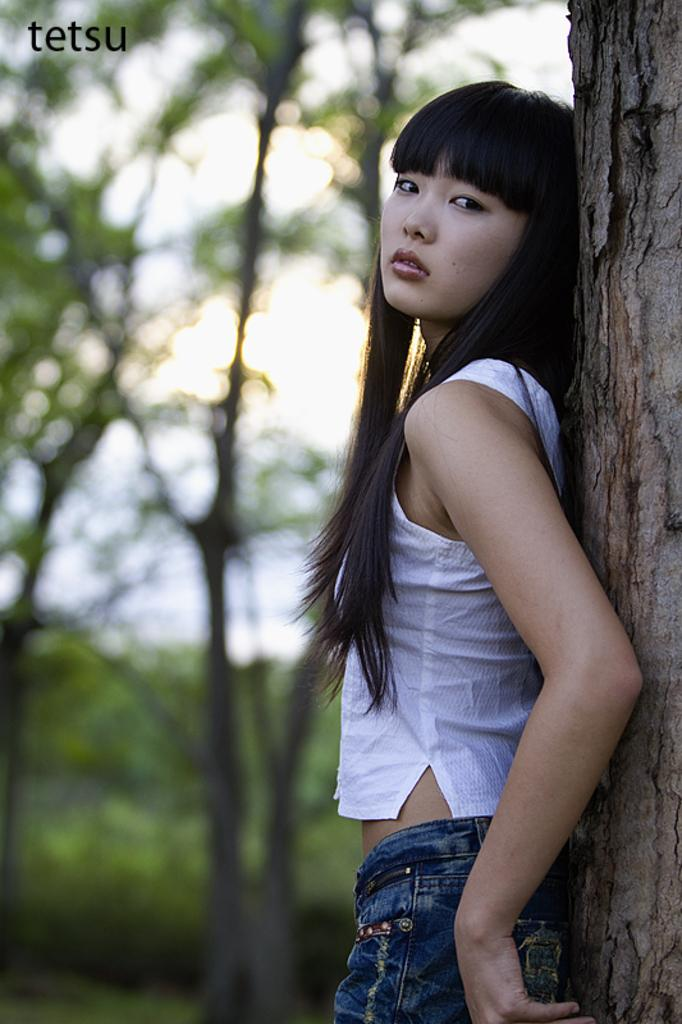Who is present in the image? There is a woman in the image. How is the woman positioned in the image? The woman is standing by leaning on a tree. What can be seen in the background of the image? There are trees, bushes, and the sky visible in the background of the image. How many dogs are playing with the monkey in the image? There are no dogs or monkeys present in the image. 